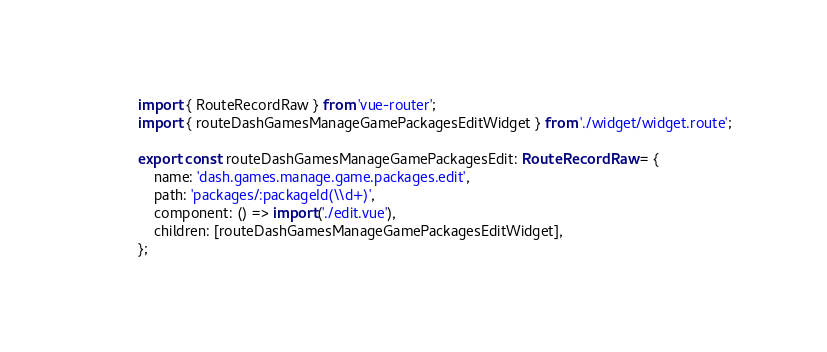<code> <loc_0><loc_0><loc_500><loc_500><_TypeScript_>import { RouteRecordRaw } from 'vue-router';
import { routeDashGamesManageGamePackagesEditWidget } from './widget/widget.route';

export const routeDashGamesManageGamePackagesEdit: RouteRecordRaw = {
	name: 'dash.games.manage.game.packages.edit',
	path: 'packages/:packageId(\\d+)',
	component: () => import('./edit.vue'),
	children: [routeDashGamesManageGamePackagesEditWidget],
};
</code> 